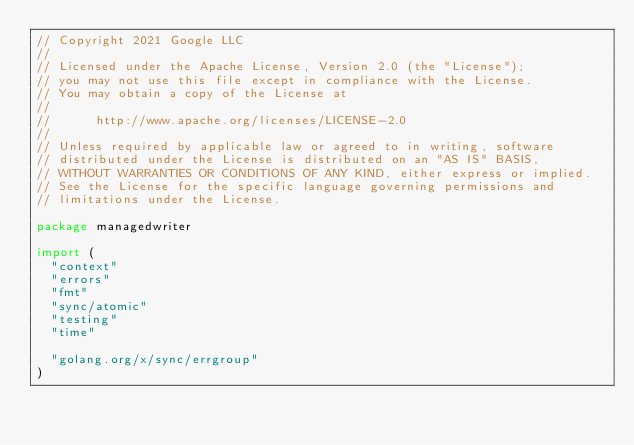Convert code to text. <code><loc_0><loc_0><loc_500><loc_500><_Go_>// Copyright 2021 Google LLC
//
// Licensed under the Apache License, Version 2.0 (the "License");
// you may not use this file except in compliance with the License.
// You may obtain a copy of the License at
//
//      http://www.apache.org/licenses/LICENSE-2.0
//
// Unless required by applicable law or agreed to in writing, software
// distributed under the License is distributed on an "AS IS" BASIS,
// WITHOUT WARRANTIES OR CONDITIONS OF ANY KIND, either express or implied.
// See the License for the specific language governing permissions and
// limitations under the License.

package managedwriter

import (
	"context"
	"errors"
	"fmt"
	"sync/atomic"
	"testing"
	"time"

	"golang.org/x/sync/errgroup"
)
</code> 